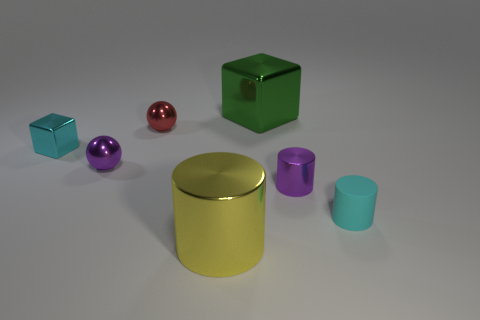Add 2 purple cylinders. How many objects exist? 9 Subtract all cyan matte cylinders. How many cylinders are left? 2 Subtract 1 cylinders. How many cylinders are left? 2 Subtract all blocks. How many objects are left? 5 Add 3 red balls. How many red balls are left? 4 Add 4 small blue metallic cubes. How many small blue metallic cubes exist? 4 Subtract 0 green spheres. How many objects are left? 7 Subtract all gray blocks. Subtract all red cylinders. How many blocks are left? 2 Subtract all tiny metal spheres. Subtract all big green objects. How many objects are left? 4 